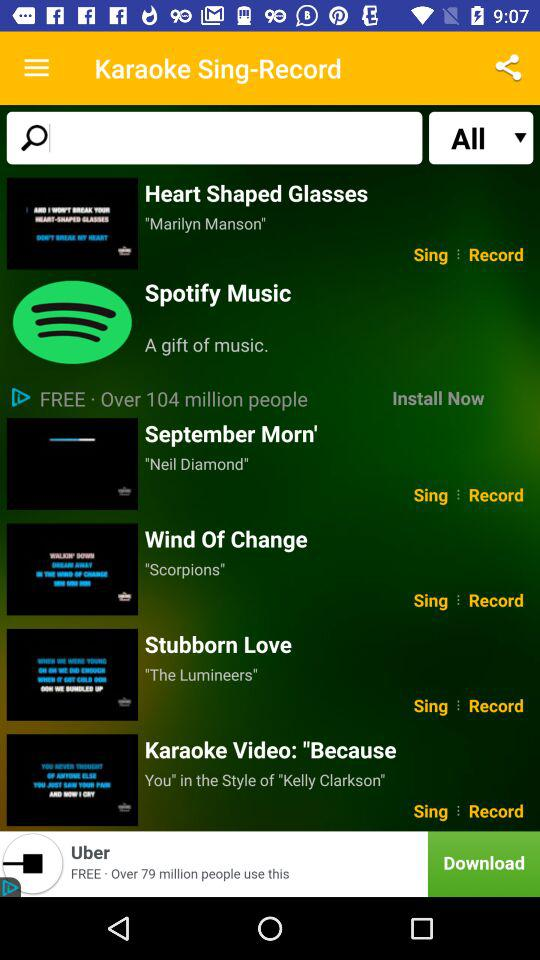Who is the singer of the song "Stubborn Love"? The singer of the song "Stubborn Love" is "The Lumineers". 